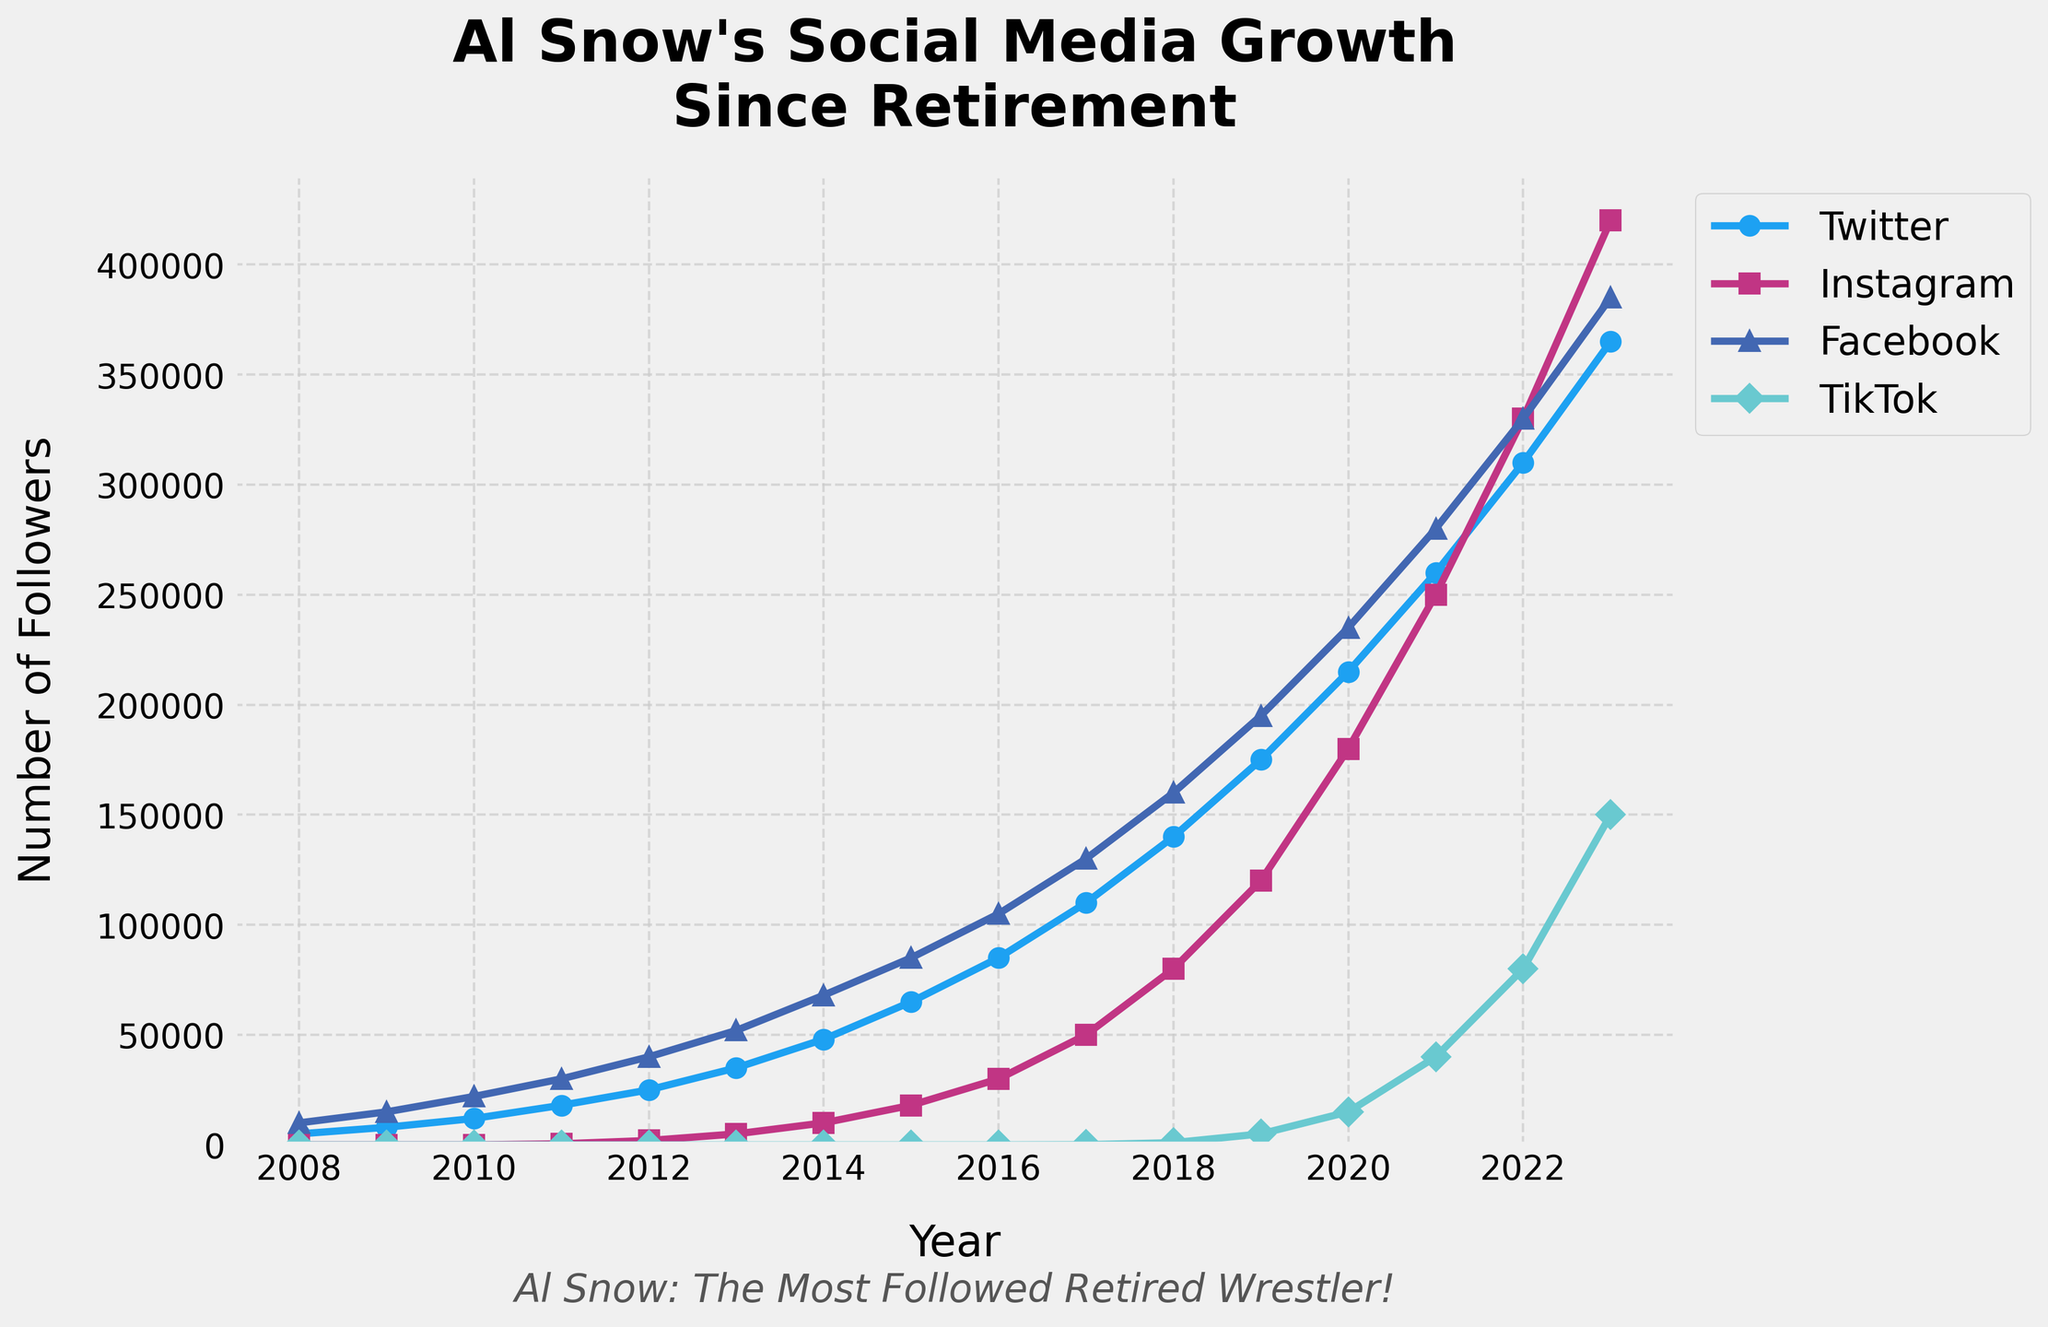Which year did Al Snow's Instagram followers first exceed 10,000? Look at the Instagram line. The followers exceed 10,000 between 2013 and 2014, so the first year it exceeded 10,000 is 2014.
Answer: 2014 Compare the total number of Twitter and Facebook followers in 2015. Which platform had more followers and by how much? Check the values for Twitter and Facebook in 2015. Twitter had 65,000 followers and Facebook had 85,000. The difference is 85,000 - 65,000 = 20,000. Facebook had more followers by 20,000.
Answer: Facebook, 20,000 In which year did TikTok see the most significant increase in followers compared to the previous year? Analyze the differences year by year. The largest increase was from 2022 to 2023, where it went from 80,000 to 150,000 (150,000 - 80,000 = 70,000).
Answer: 2022 to 2023 How many years did it take for Al Snow's Twitter followers to grow from 8,000 to over 200,000? Identify the years corresponding to 8,000 followers (2009) and over 200,000 followers (2020). The difference is 2020 - 2009 = 11 years.
Answer: 11 years By what factor did Al Snow's Instagram followers increase from 2012 to 2019? Instagram followers in 2012 were 2,000 and in 2019 were 120,000. The factor of increase is 120,000 / 2,000 = 60.
Answer: 60 Which platform had the highest number of followers in 2020? Compare the values for all platforms in 2020. Facebook had 235,000 followers, the highest among all platforms.
Answer: Facebook Between which consecutive years did Facebook see its highest increase in followers? Calculate the differences year by year for Facebook. The highest increase is from 2014 to 2015, with an increase of 85,000 - 68,000 = 17,000 followers.
Answer: 2014 to 2015 What is the average number of Instagram followers from 2015 to 2020? Sum the number of Instagram followers from 2015 (18,000) to 2020 (180,000) and divide by the number of years (6). (18,000 + 30,000 + 50,000 + 80,000 + 120,000 + 180,000) / 6 = 478,000 / 6 ≈ 79,667.
Answer: 79,667 What is the median number of TikTok followers from 2017 to 2023? List the TikTok followers: [100, 1000, 5000, 15000, 40000, 80000, 150000]. The median value is 15,000 (since it is the middle value of the list).
Answer: 15000 